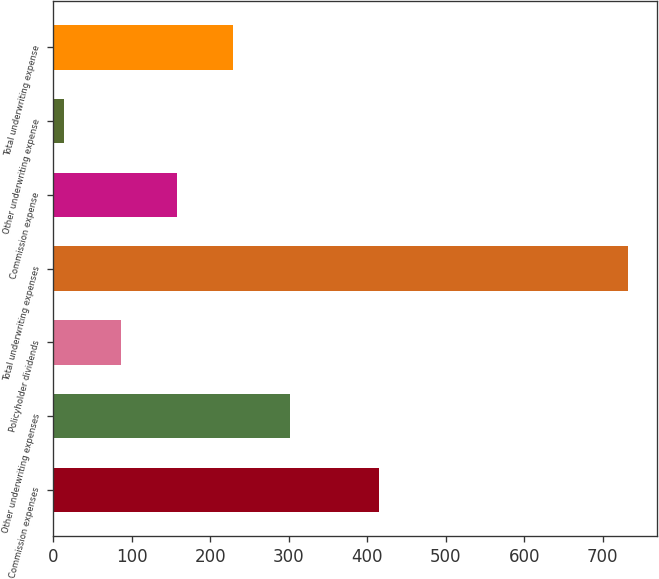Convert chart. <chart><loc_0><loc_0><loc_500><loc_500><bar_chart><fcel>Commission expenses<fcel>Other underwriting expenses<fcel>Policyholder dividends<fcel>Total underwriting expenses<fcel>Commission expense<fcel>Other underwriting expense<fcel>Total underwriting expense<nl><fcel>415<fcel>301.08<fcel>85.62<fcel>732<fcel>157.44<fcel>13.8<fcel>229.26<nl></chart> 